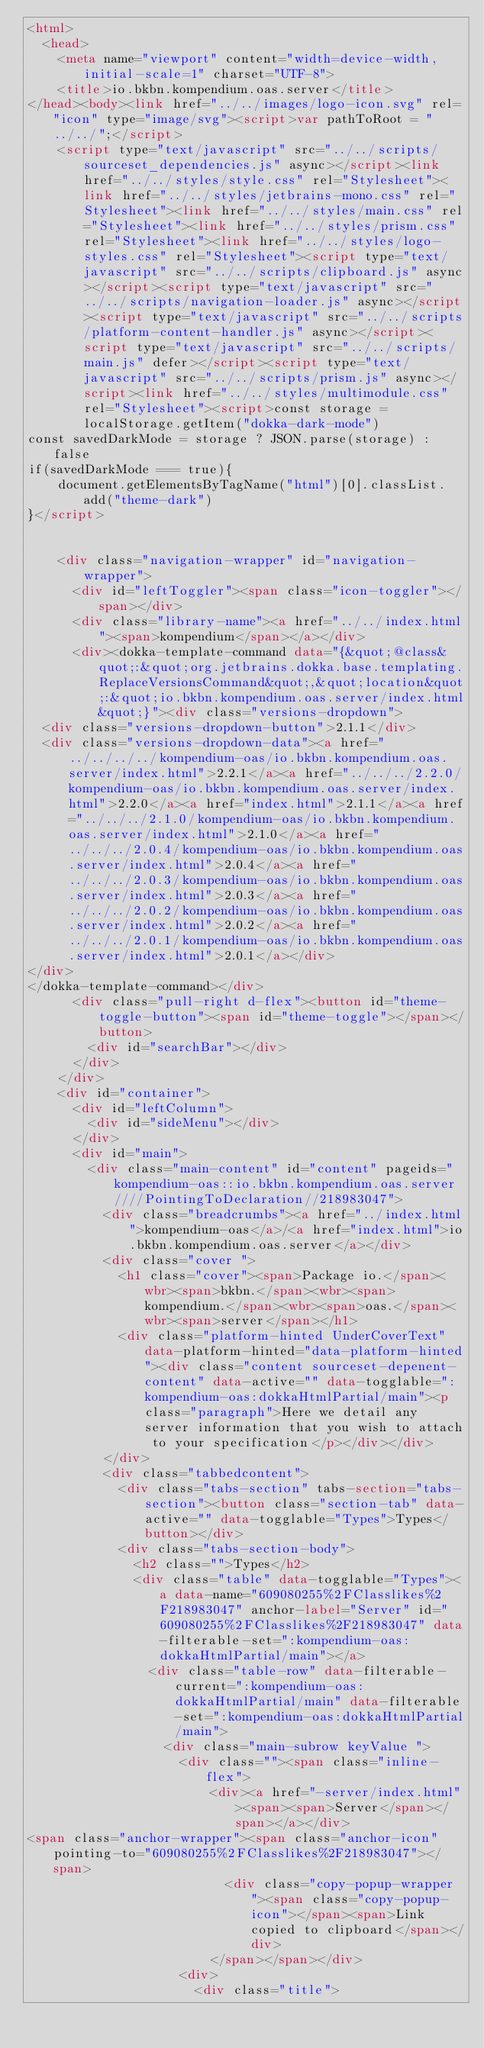<code> <loc_0><loc_0><loc_500><loc_500><_HTML_><html>
  <head>
    <meta name="viewport" content="width=device-width, initial-scale=1" charset="UTF-8">
    <title>io.bkbn.kompendium.oas.server</title>
</head><body><link href="../../images/logo-icon.svg" rel="icon" type="image/svg"><script>var pathToRoot = "../../";</script>
    <script type="text/javascript" src="../../scripts/sourceset_dependencies.js" async></script><link href="../../styles/style.css" rel="Stylesheet"><link href="../../styles/jetbrains-mono.css" rel="Stylesheet"><link href="../../styles/main.css" rel="Stylesheet"><link href="../../styles/prism.css" rel="Stylesheet"><link href="../../styles/logo-styles.css" rel="Stylesheet"><script type="text/javascript" src="../../scripts/clipboard.js" async></script><script type="text/javascript" src="../../scripts/navigation-loader.js" async></script><script type="text/javascript" src="../../scripts/platform-content-handler.js" async></script><script type="text/javascript" src="../../scripts/main.js" defer></script><script type="text/javascript" src="../../scripts/prism.js" async></script><link href="../../styles/multimodule.css" rel="Stylesheet"><script>const storage = localStorage.getItem("dokka-dark-mode")
const savedDarkMode = storage ? JSON.parse(storage) : false
if(savedDarkMode === true){
    document.getElementsByTagName("html")[0].classList.add("theme-dark")
}</script>

  
    <div class="navigation-wrapper" id="navigation-wrapper">
      <div id="leftToggler"><span class="icon-toggler"></span></div>
      <div class="library-name"><a href="../../index.html"><span>kompendium</span></a></div>
      <div><dokka-template-command data="{&quot;@class&quot;:&quot;org.jetbrains.dokka.base.templating.ReplaceVersionsCommand&quot;,&quot;location&quot;:&quot;io.bkbn.kompendium.oas.server/index.html&quot;}"><div class="versions-dropdown">
  <div class="versions-dropdown-button">2.1.1</div>
  <div class="versions-dropdown-data"><a href="../../../../kompendium-oas/io.bkbn.kompendium.oas.server/index.html">2.2.1</a><a href="../../../2.2.0/kompendium-oas/io.bkbn.kompendium.oas.server/index.html">2.2.0</a><a href="index.html">2.1.1</a><a href="../../../2.1.0/kompendium-oas/io.bkbn.kompendium.oas.server/index.html">2.1.0</a><a href="../../../2.0.4/kompendium-oas/io.bkbn.kompendium.oas.server/index.html">2.0.4</a><a href="../../../2.0.3/kompendium-oas/io.bkbn.kompendium.oas.server/index.html">2.0.3</a><a href="../../../2.0.2/kompendium-oas/io.bkbn.kompendium.oas.server/index.html">2.0.2</a><a href="../../../2.0.1/kompendium-oas/io.bkbn.kompendium.oas.server/index.html">2.0.1</a></div>
</div>
</dokka-template-command></div>
      <div class="pull-right d-flex"><button id="theme-toggle-button"><span id="theme-toggle"></span></button>
        <div id="searchBar"></div>
      </div>
    </div>
    <div id="container">
      <div id="leftColumn">
        <div id="sideMenu"></div>
      </div>
      <div id="main">
        <div class="main-content" id="content" pageids="kompendium-oas::io.bkbn.kompendium.oas.server////PointingToDeclaration//218983047">
          <div class="breadcrumbs"><a href="../index.html">kompendium-oas</a>/<a href="index.html">io.bkbn.kompendium.oas.server</a></div>
          <div class="cover ">
            <h1 class="cover"><span>Package io.</span><wbr><span>bkbn.</span><wbr><span>kompendium.</span><wbr><span>oas.</span><wbr><span>server</span></h1>
            <div class="platform-hinted UnderCoverText" data-platform-hinted="data-platform-hinted"><div class="content sourceset-depenent-content" data-active="" data-togglable=":kompendium-oas:dokkaHtmlPartial/main"><p class="paragraph">Here we detail any server information that you wish to attach to your specification</p></div></div>
          </div>
          <div class="tabbedcontent">
            <div class="tabs-section" tabs-section="tabs-section"><button class="section-tab" data-active="" data-togglable="Types">Types</button></div>
            <div class="tabs-section-body">
              <h2 class="">Types</h2>
              <div class="table" data-togglable="Types"><a data-name="609080255%2FClasslikes%2F218983047" anchor-label="Server" id="609080255%2FClasslikes%2F218983047" data-filterable-set=":kompendium-oas:dokkaHtmlPartial/main"></a>
                <div class="table-row" data-filterable-current=":kompendium-oas:dokkaHtmlPartial/main" data-filterable-set=":kompendium-oas:dokkaHtmlPartial/main">
                  <div class="main-subrow keyValue ">
                    <div class=""><span class="inline-flex">
                        <div><a href="-server/index.html"><span><span>Server</span></span></a></div>
<span class="anchor-wrapper"><span class="anchor-icon" pointing-to="609080255%2FClasslikes%2F218983047"></span>
                          <div class="copy-popup-wrapper "><span class="copy-popup-icon"></span><span>Link copied to clipboard</span></div>
                        </span></span></div>
                    <div>
                      <div class="title"></code> 